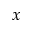Convert formula to latex. <formula><loc_0><loc_0><loc_500><loc_500>x</formula> 